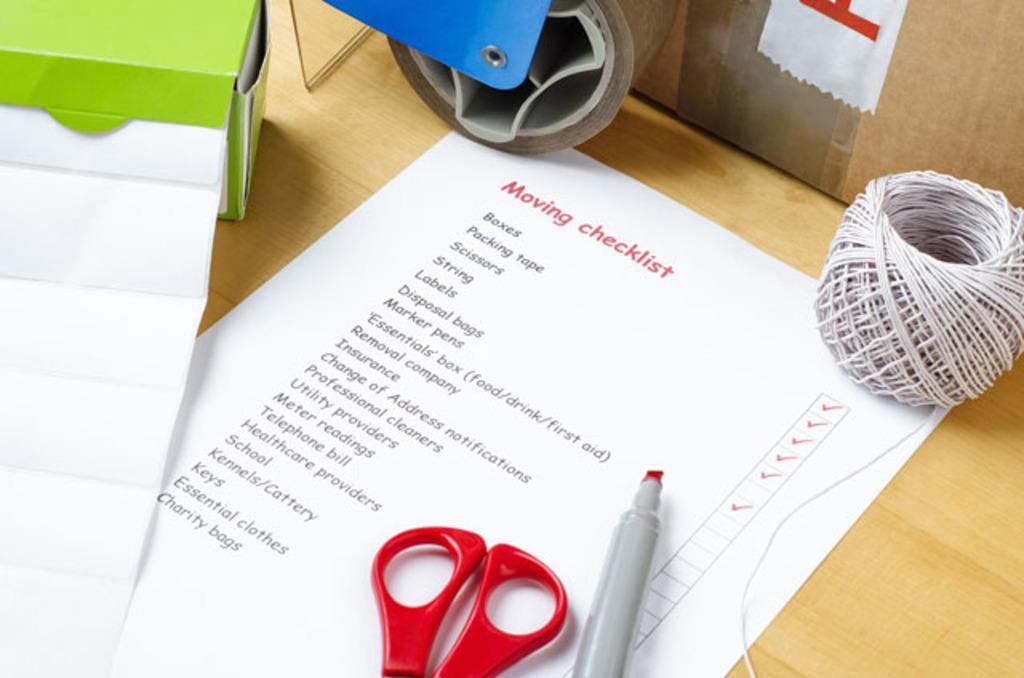Please provide a concise description of this image. On the table we can see a paper, pen, scissor, cotton box, wire and plaster. Beside that we can see the cotton box. 